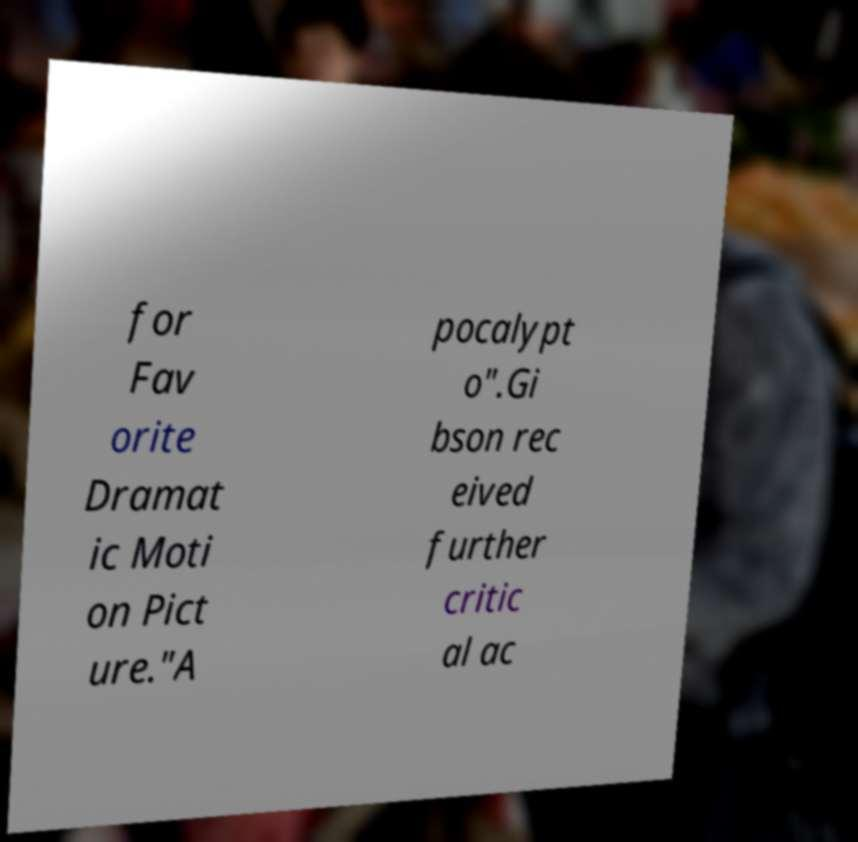Please read and relay the text visible in this image. What does it say? for Fav orite Dramat ic Moti on Pict ure."A pocalypt o".Gi bson rec eived further critic al ac 